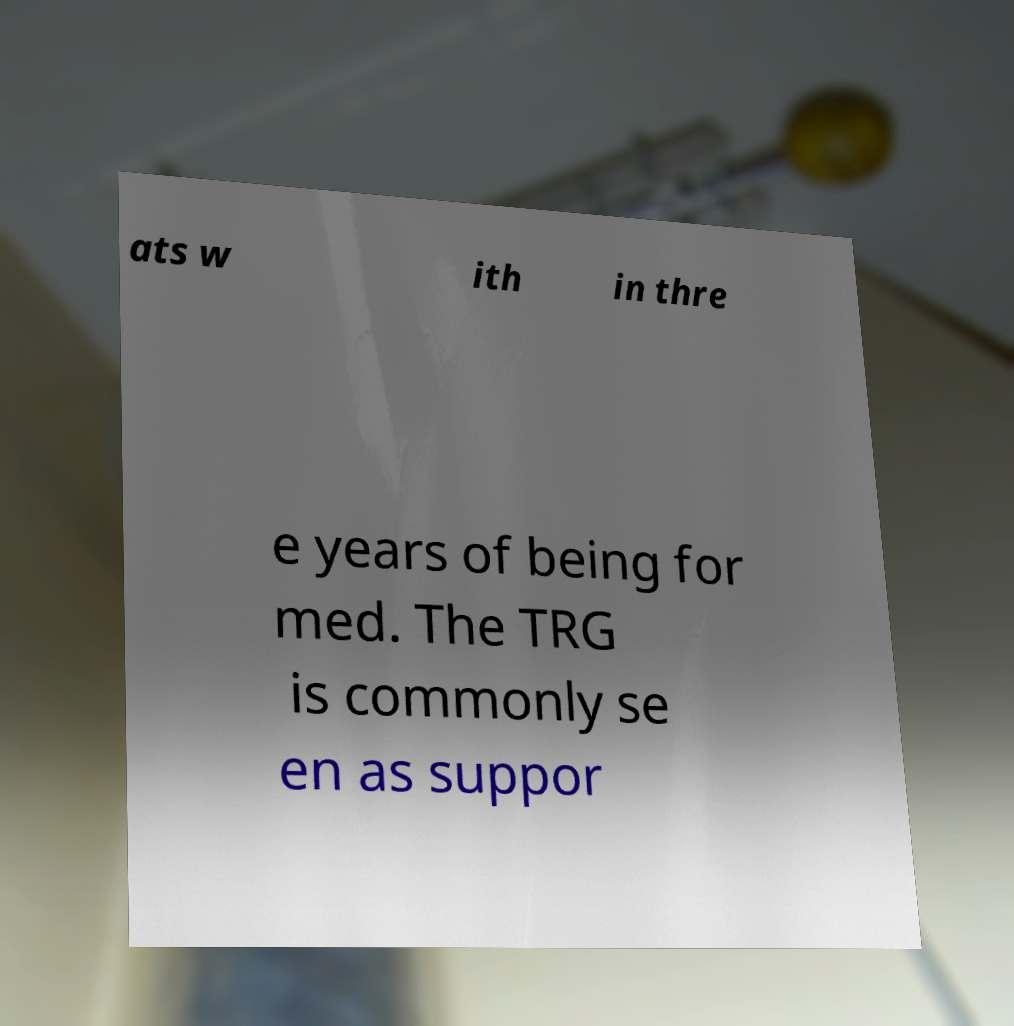Please read and relay the text visible in this image. What does it say? ats w ith in thre e years of being for med. The TRG is commonly se en as suppor 